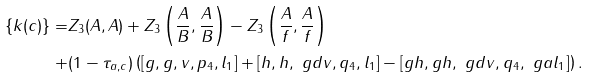Convert formula to latex. <formula><loc_0><loc_0><loc_500><loc_500>\{ k ( c ) \} = & Z _ { 3 } ( A , A ) + Z _ { 3 } \left ( \frac { A } { B } , \frac { A } { B } \right ) - Z _ { 3 } \left ( \frac { A } { f } , \frac { A } { f } \right ) \\ + & ( 1 - \tau _ { a , c } ) \left ( [ g , g , v , p _ { 4 } , l _ { 1 } ] + [ h , h , \ g d v , q _ { 4 } , l _ { 1 } ] - [ g h , g h , \ g d v , q _ { 4 } , \ g a l _ { 1 } ] \right ) .</formula> 